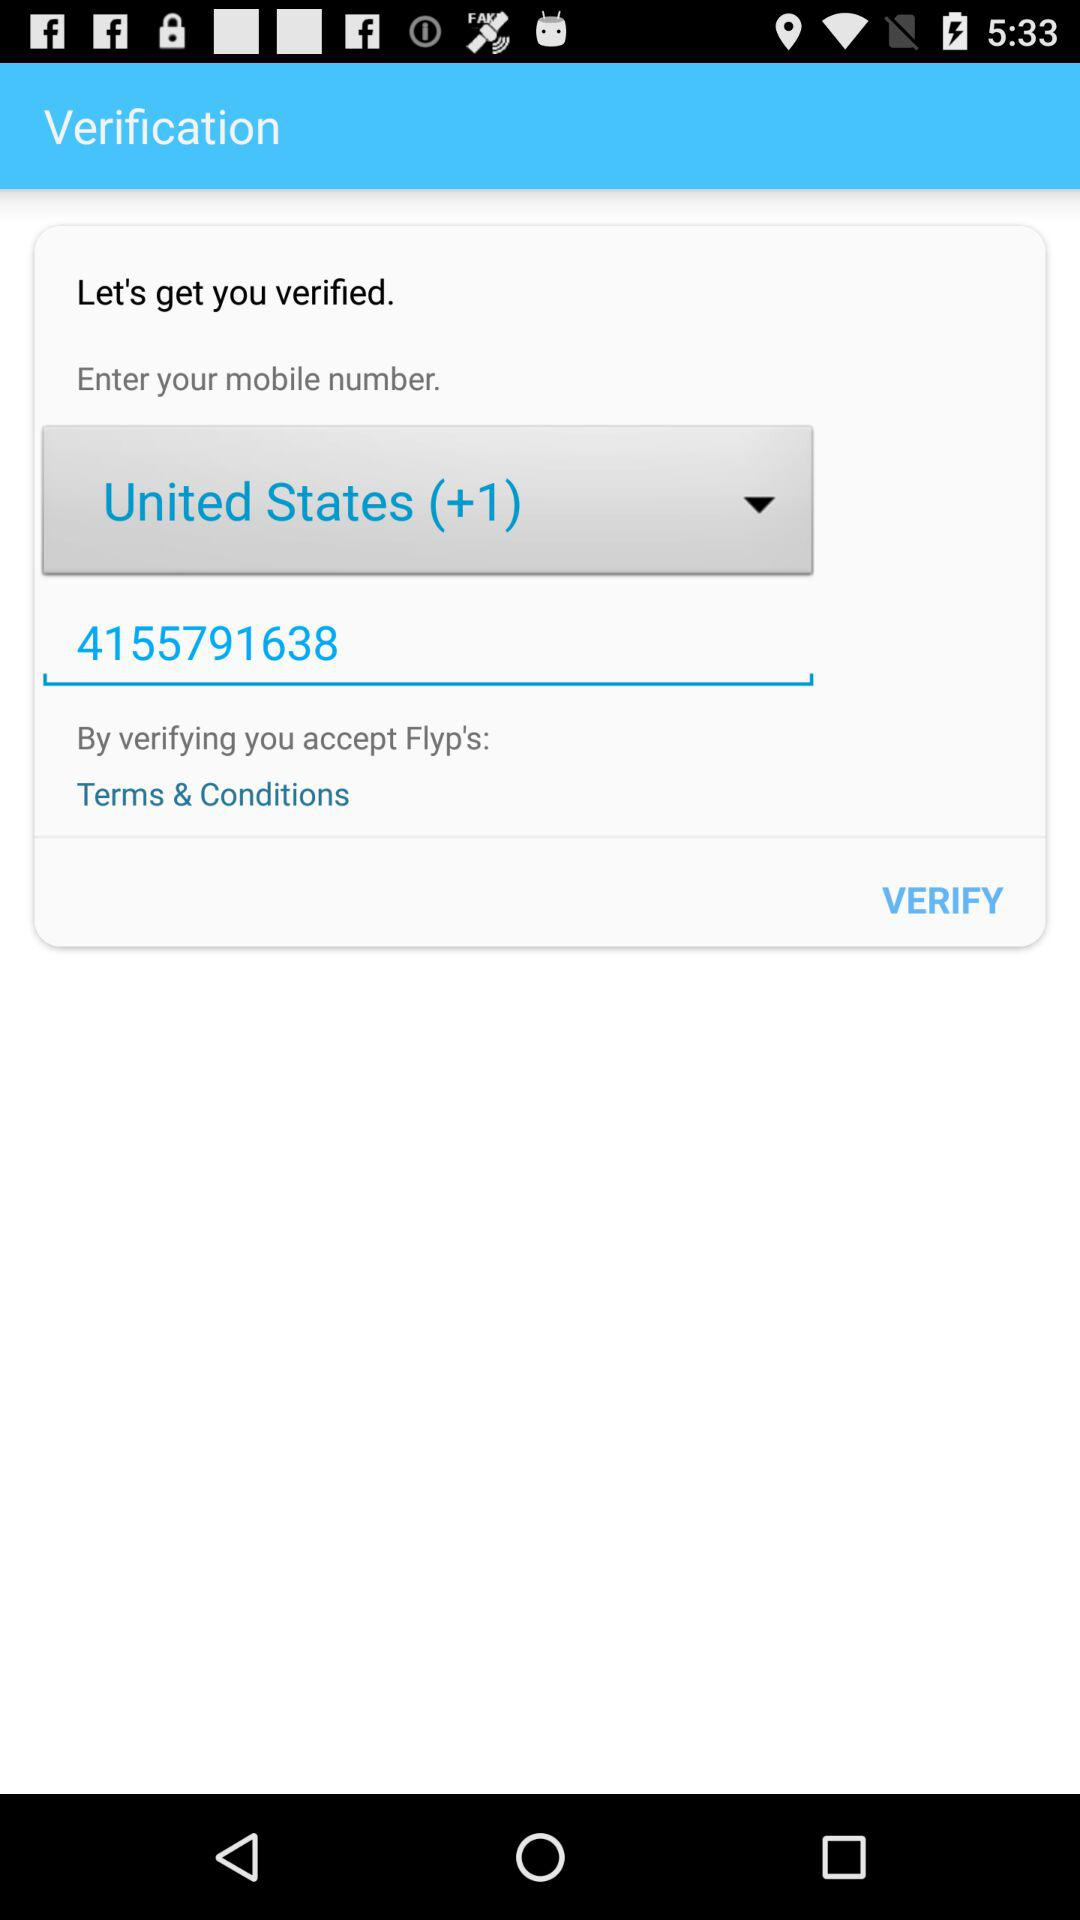What is the phone number? The phone number is 4155791638. 